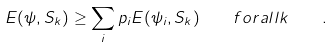Convert formula to latex. <formula><loc_0><loc_0><loc_500><loc_500>E ( \psi , S _ { k } ) \geq \sum _ { i } p _ { i } E ( \psi _ { i } , S _ { k } ) \quad f o r a l l k \quad .</formula> 